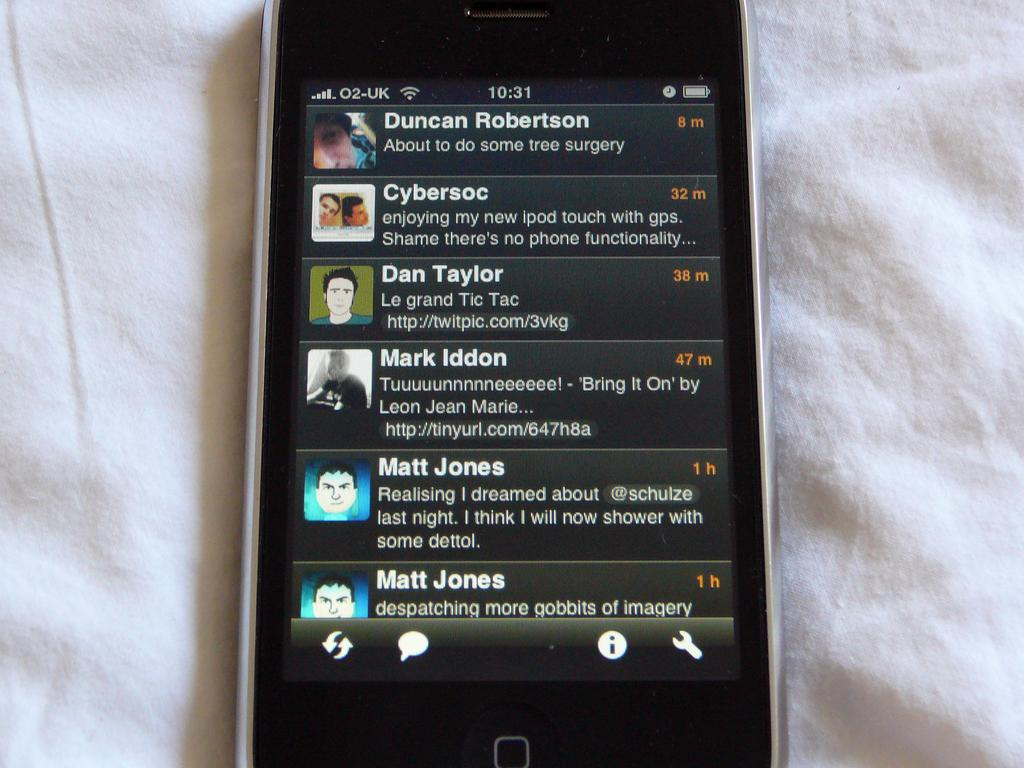<image>
Write a terse but informative summary of the picture. a phone with the word cybersoc on it 